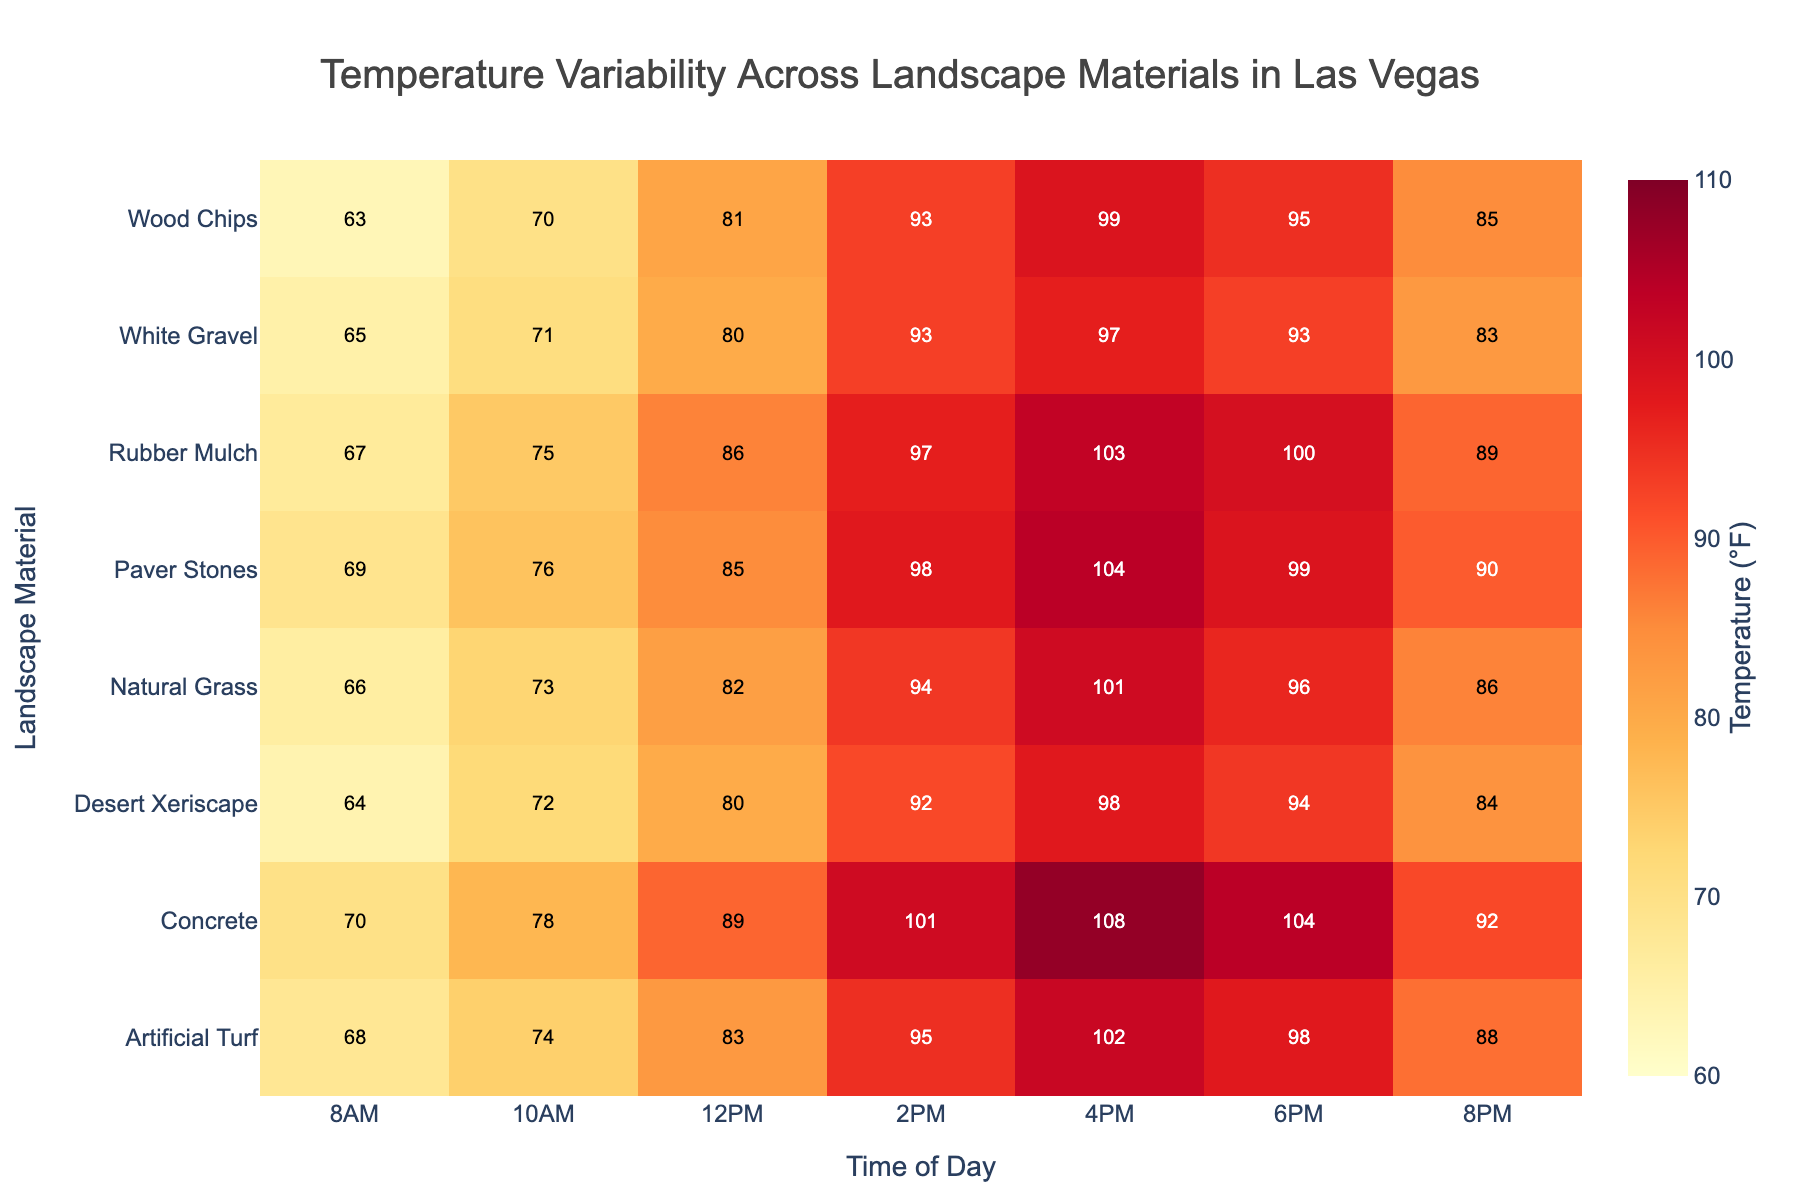What is the temperature range shown on the color bar? The figure has a color bar on the right side, which displays the temperature range from 60°F to 110°F.
Answer: 60°F to 110°F At what time does Concrete reach its peak temperature? By looking at the heatmap, the highest temperature for Concrete appears at 4 PM, indicated by the darkest shade in its row.
Answer: 4 PM Which material has the lowest temperature at 8 AM? At 8 AM, the lowest value indicated is for Wood Chips, which is 63°F.
Answer: Wood Chips What is the temperature difference between Artificial Turf and Natural Grass at 2 PM? The heatmap shows the temperature for Artificial Turf at 2 PM is 95°F and for Natural Grass is 94°F. The difference is 95 - 94 = 1°F.
Answer: 1°F Which landscape material shows the highest temperature at 6 PM? By comparing the temperatures in the heatmap for 6 PM across all materials, Concrete has the highest value, which is 104°F.
Answer: Concrete What is the average temperature of Desert Xeriscape throughout the day? Summing up the temperatures for Desert Xeriscape (64 + 72 + 80 + 92 + 98 + 94 + 84) gives 584. There are 7 time points, so the average is 584/7 ≈ 83.43°F.
Answer: 83.43°F Which two materials show the least temperature variation throughout the day? By examining the heatmap rows visually, White Gravel and Wood Chips have the least variation since their color gradient looks more consistent with lighter shades.
Answer: White Gravel and Wood Chips How does the temperature at 8 PM for Rubber Mulch compare to the temperature at 8 PM for Artificial Turf? The heatmap indicates that at 8 PM, Rubber Mulch is 89°F and Artificial Turf is 88°F. Rubber Mulch is 1°F higher than Artificial Turf.
Answer: 1°F higher What is the temperature trend for Paver Stones from 8 AM to 8 PM? Observing the Paver Stones row, the temperature increases from 69°F at 8 AM to a peak of 104°F at 4 PM and then decreases to 90°F by 8 PM, showing an upward trend followed by a decline.
Answer: Increases then decreases Identify which material has close to a constant temperature from 10 AM to 6 PM. White Gravel appears almost constant with temperatures from 10 AM to 6 PM showing little variation (71, 80, 93, 97, 93).
Answer: White Gravel 